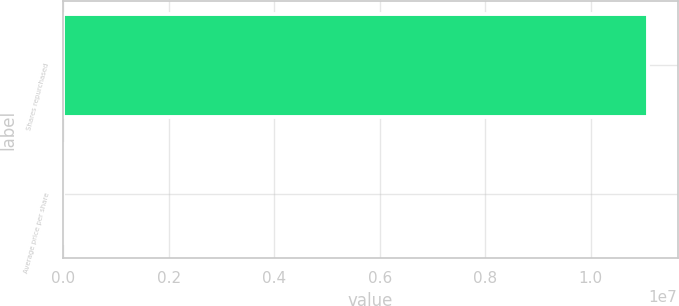Convert chart to OTSL. <chart><loc_0><loc_0><loc_500><loc_500><bar_chart><fcel>Shares repurchased<fcel>Average price per share<nl><fcel>1.10918e+07<fcel>125.64<nl></chart> 